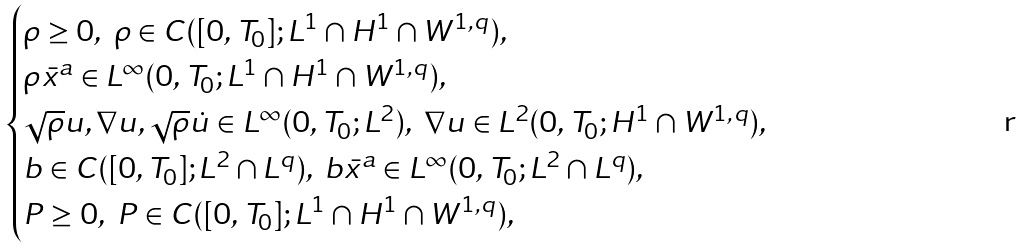Convert formula to latex. <formula><loc_0><loc_0><loc_500><loc_500>\begin{cases} \rho \geq 0 , \ \rho \in C ( [ 0 , T _ { 0 } ] ; L ^ { 1 } \cap H ^ { 1 } \cap W ^ { 1 , q } ) , \\ \rho \bar { x } ^ { a } \in L ^ { \infty } ( 0 , T _ { 0 } ; L ^ { 1 } \cap H ^ { 1 } \cap W ^ { 1 , q } ) , \\ \sqrt { \rho } u , \nabla u , \sqrt { \rho } \dot { u } \in L ^ { \infty } ( 0 , T _ { 0 } ; L ^ { 2 } ) , \ \nabla u \in L ^ { 2 } ( 0 , T _ { 0 } ; H ^ { 1 } \cap W ^ { 1 , q } ) , \\ b \in C ( [ 0 , T _ { 0 } ] ; L ^ { 2 } \cap L ^ { q } ) , \ b \bar { x } ^ { a } \in L ^ { \infty } ( 0 , T _ { 0 } ; L ^ { 2 } \cap L ^ { q } ) , \\ P \geq 0 , \ P \in C ( [ 0 , T _ { 0 } ] ; L ^ { 1 } \cap H ^ { 1 } \cap W ^ { 1 , q } ) , \end{cases}</formula> 